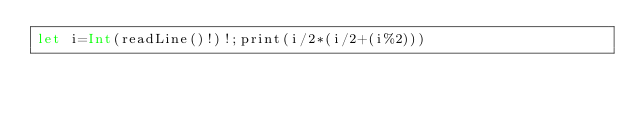Convert code to text. <code><loc_0><loc_0><loc_500><loc_500><_Swift_>let i=Int(readLine()!)!;print(i/2*(i/2+(i%2)))</code> 